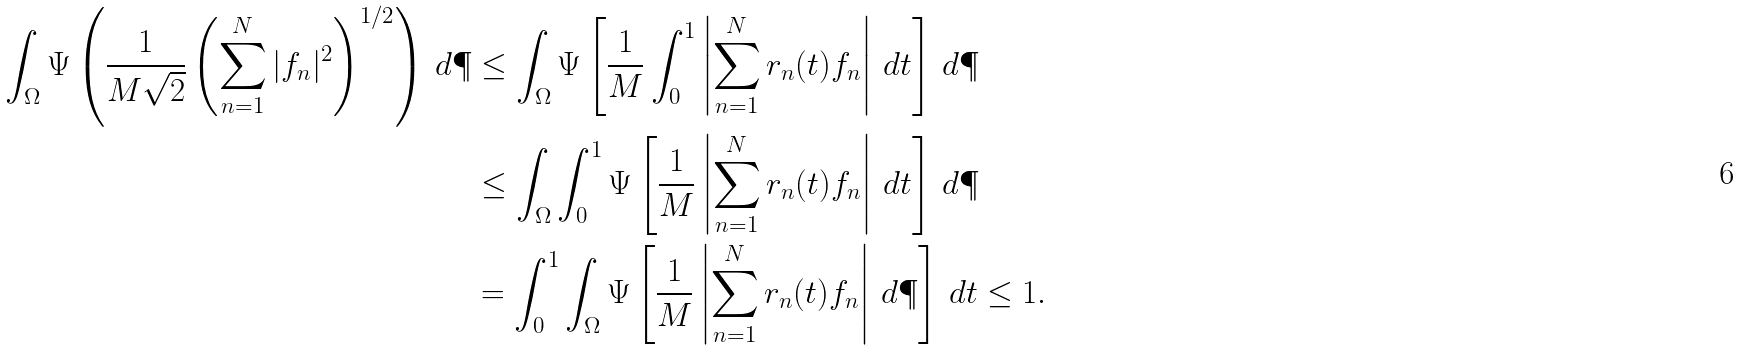<formula> <loc_0><loc_0><loc_500><loc_500>\int _ { \Omega } \Psi \left ( \frac { 1 } { M \sqrt { 2 } } \left ( \sum _ { n = 1 } ^ { N } | f _ { n } | ^ { 2 } \right ) ^ { 1 / 2 } \right ) \, d \P & \leq \int _ { \Omega } \Psi \left [ \frac { 1 } { M } \int _ { 0 } ^ { 1 } \left | \sum _ { n = 1 } ^ { N } r _ { n } ( t ) f _ { n } \right | \, d t \right ] \, d \P \\ & \leq \int _ { \Omega } \int _ { 0 } ^ { 1 } \Psi \left [ \frac { 1 } { M } \left | \sum _ { n = 1 } ^ { N } r _ { n } ( t ) f _ { n } \right | \, d t \right ] \, d \P \\ & = \int _ { 0 } ^ { 1 } \int _ { \Omega } \Psi \left [ \frac { 1 } { M } \left | \sum _ { n = 1 } ^ { N } r _ { n } ( t ) f _ { n } \right | \, d \P \right ] \, d t \leq 1 .</formula> 